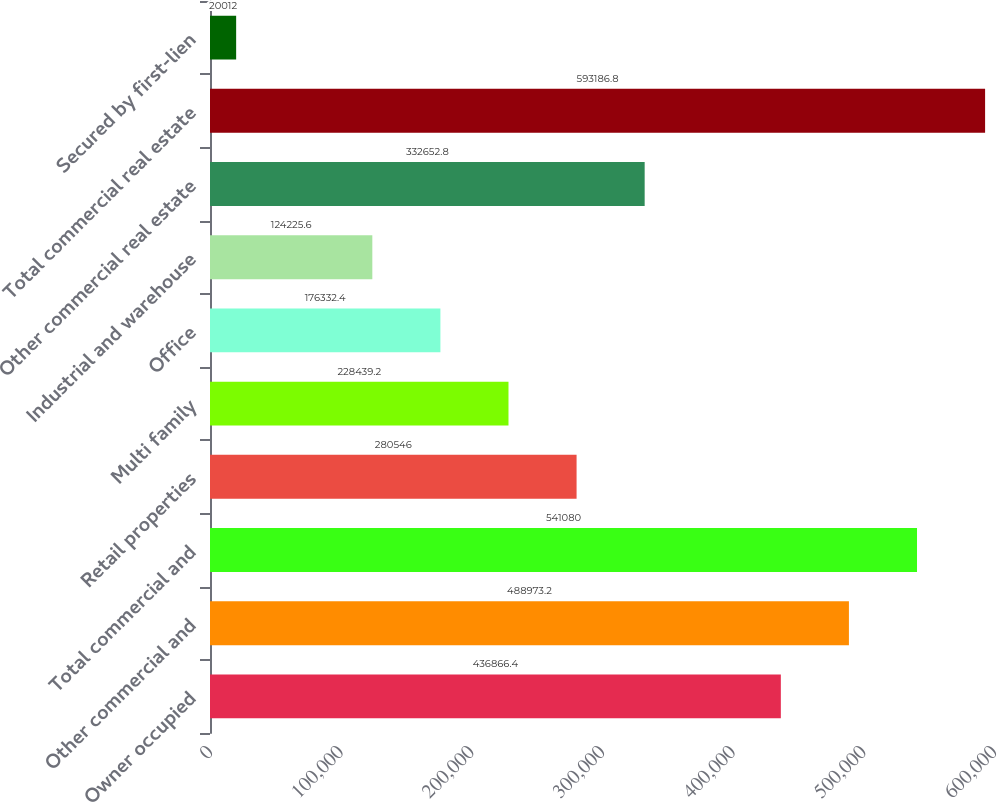Convert chart. <chart><loc_0><loc_0><loc_500><loc_500><bar_chart><fcel>Owner occupied<fcel>Other commercial and<fcel>Total commercial and<fcel>Retail properties<fcel>Multi family<fcel>Office<fcel>Industrial and warehouse<fcel>Other commercial real estate<fcel>Total commercial real estate<fcel>Secured by first-lien<nl><fcel>436866<fcel>488973<fcel>541080<fcel>280546<fcel>228439<fcel>176332<fcel>124226<fcel>332653<fcel>593187<fcel>20012<nl></chart> 